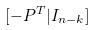<formula> <loc_0><loc_0><loc_500><loc_500>[ - P ^ { T } | I _ { n - k } ]</formula> 